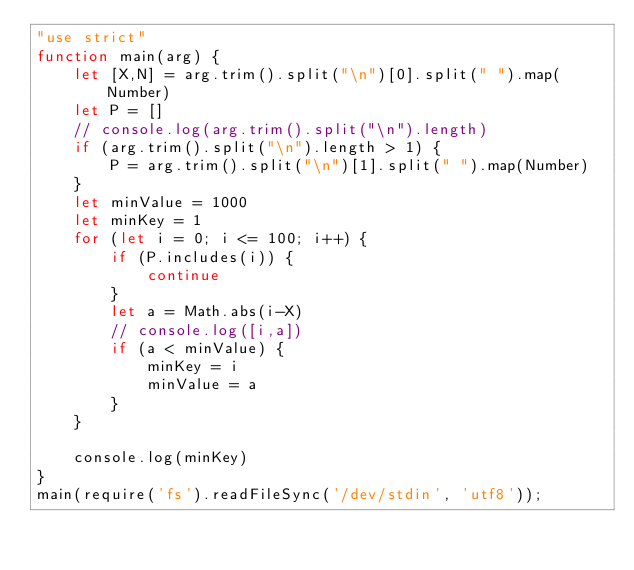Convert code to text. <code><loc_0><loc_0><loc_500><loc_500><_JavaScript_>"use strict"
function main(arg) {
    let [X,N] = arg.trim().split("\n")[0].split(" ").map(Number)
    let P = []
    // console.log(arg.trim().split("\n").length)
    if (arg.trim().split("\n").length > 1) {
        P = arg.trim().split("\n")[1].split(" ").map(Number)
    } 
    let minValue = 1000
    let minKey = 1
    for (let i = 0; i <= 100; i++) {
        if (P.includes(i)) {
            continue
        }
        let a = Math.abs(i-X)
        // console.log([i,a])
        if (a < minValue) {
            minKey = i
            minValue = a
        }
    }
    
    console.log(minKey)
}
main(require('fs').readFileSync('/dev/stdin', 'utf8'));</code> 